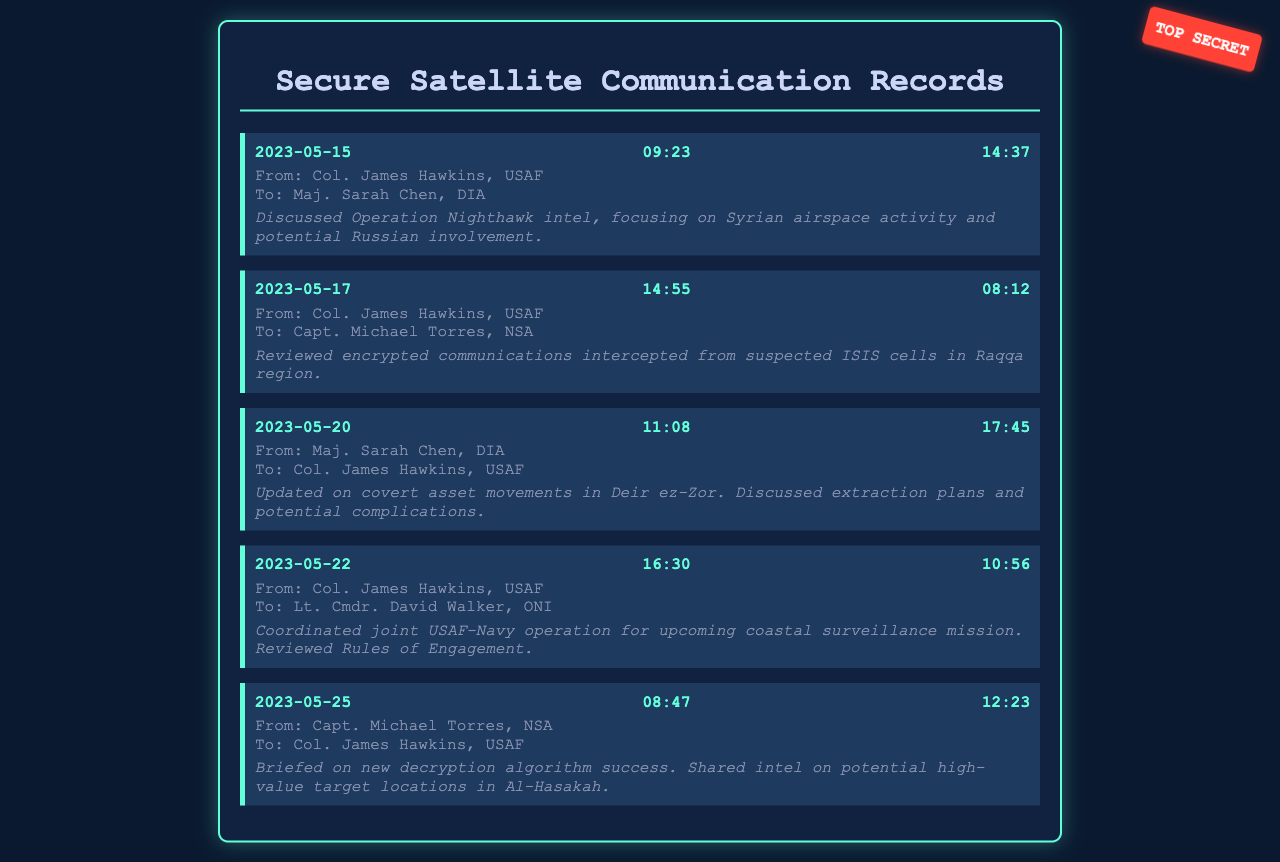What is the date of the first call? The first call is dated May 15, 2023.
Answer: May 15, 2023 Who initiated the call on May 20, 2023? The call on May 20, 2023, was initiated by Maj. Sarah Chen, DIA.
Answer: Maj. Sarah Chen, DIA How long did the call on May 25, 2023, last? The duration of the call on May 25, 2023, was 12 minutes and 23 seconds.
Answer: 12:23 What was the main topic discussed in the call on May 22, 2023? The main topic discussed was the coordination of a joint USAF-Navy operation for coastal surveillance.
Answer: Coastal surveillance mission Which intelligence officer was addressed by Col. James Hawkins on May 17, 2023? Col. James Hawkins addressed Capt. Michael Torres, NSA on May 17, 2023.
Answer: Capt. Michael Torres, NSA Why was the call on May 20, 2023, significant? The call was significant for updating on covert asset movements and discussing extraction plans.
Answer: Covert asset movements What organization does Col. James Hawkins belong to? Col. James Hawkins belongs to the United States Air Force.
Answer: USAF What was discussed in terms of technology during the May 25, 2023, call? The discussion included success with a new decryption algorithm.
Answer: New decryption algorithm What was the time of the call on May 17, 2023? The time of the call on May 17, 2023, was 14:55.
Answer: 14:55 